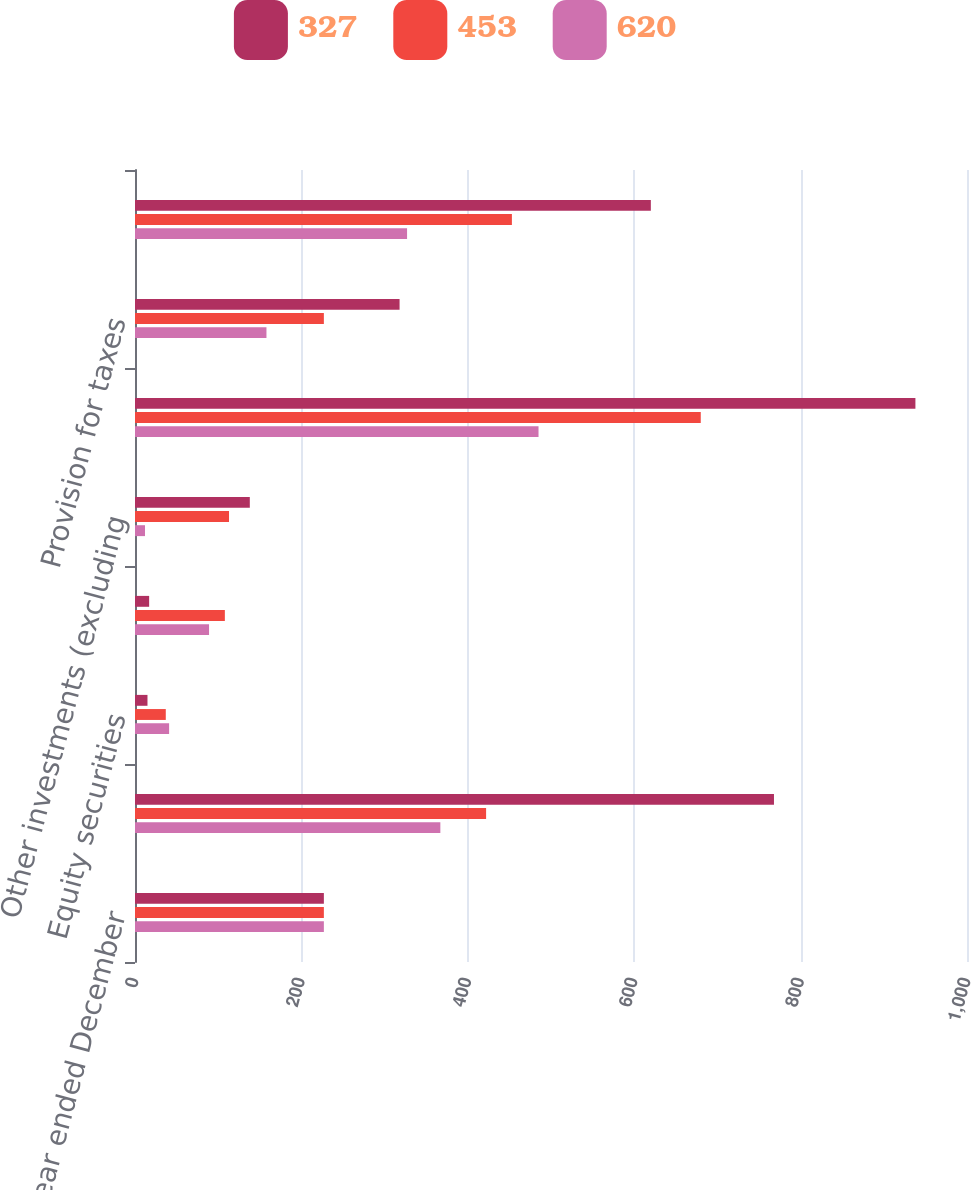Convert chart to OTSL. <chart><loc_0><loc_0><loc_500><loc_500><stacked_bar_chart><ecel><fcel>(for the year ended December<fcel>Fixed maturities<fcel>Equity securities<fcel>Venture capital<fcel>Other investments (excluding<fcel>Unrealized investment gains<fcel>Provision for taxes<fcel>Net unrealized investment<nl><fcel>327<fcel>227<fcel>768<fcel>15<fcel>17<fcel>138<fcel>938<fcel>318<fcel>620<nl><fcel>453<fcel>227<fcel>422<fcel>37<fcel>108<fcel>113<fcel>680<fcel>227<fcel>453<nl><fcel>620<fcel>227<fcel>367<fcel>41<fcel>89<fcel>12<fcel>485<fcel>158<fcel>327<nl></chart> 